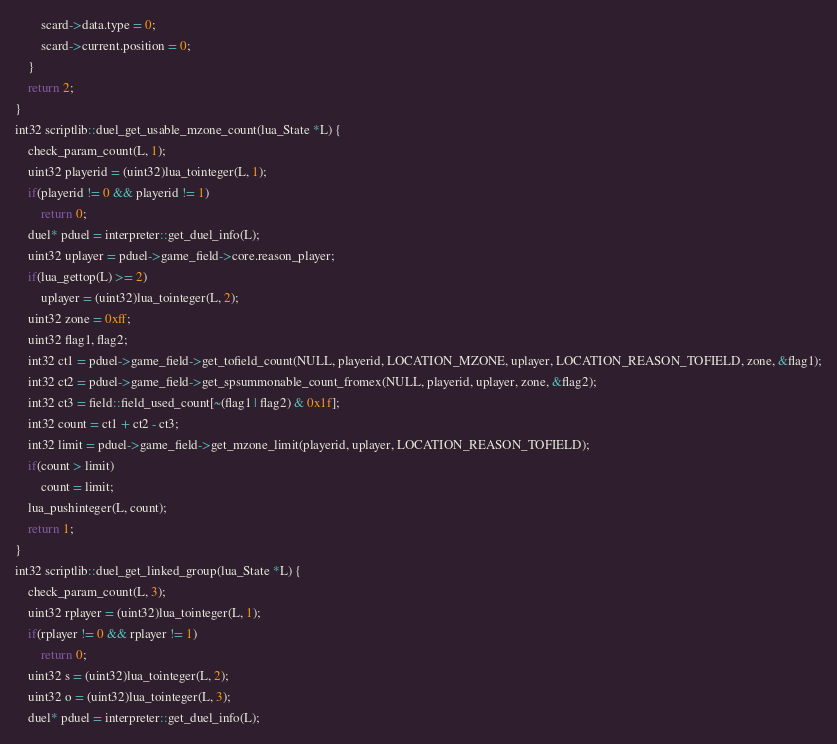<code> <loc_0><loc_0><loc_500><loc_500><_C++_>		scard->data.type = 0;
		scard->current.position = 0;
	}
	return 2;
}
int32 scriptlib::duel_get_usable_mzone_count(lua_State *L) {
	check_param_count(L, 1);
	uint32 playerid = (uint32)lua_tointeger(L, 1);
	if(playerid != 0 && playerid != 1)
		return 0;
	duel* pduel = interpreter::get_duel_info(L);
	uint32 uplayer = pduel->game_field->core.reason_player;
	if(lua_gettop(L) >= 2)
		uplayer = (uint32)lua_tointeger(L, 2);
	uint32 zone = 0xff;
	uint32 flag1, flag2;
	int32 ct1 = pduel->game_field->get_tofield_count(NULL, playerid, LOCATION_MZONE, uplayer, LOCATION_REASON_TOFIELD, zone, &flag1);
	int32 ct2 = pduel->game_field->get_spsummonable_count_fromex(NULL, playerid, uplayer, zone, &flag2);
	int32 ct3 = field::field_used_count[~(flag1 | flag2) & 0x1f];
	int32 count = ct1 + ct2 - ct3;
	int32 limit = pduel->game_field->get_mzone_limit(playerid, uplayer, LOCATION_REASON_TOFIELD);
	if(count > limit)
		count = limit;
	lua_pushinteger(L, count);
	return 1;
}
int32 scriptlib::duel_get_linked_group(lua_State *L) {
	check_param_count(L, 3);
	uint32 rplayer = (uint32)lua_tointeger(L, 1);
	if(rplayer != 0 && rplayer != 1)
		return 0;
	uint32 s = (uint32)lua_tointeger(L, 2);
	uint32 o = (uint32)lua_tointeger(L, 3);
	duel* pduel = interpreter::get_duel_info(L);</code> 